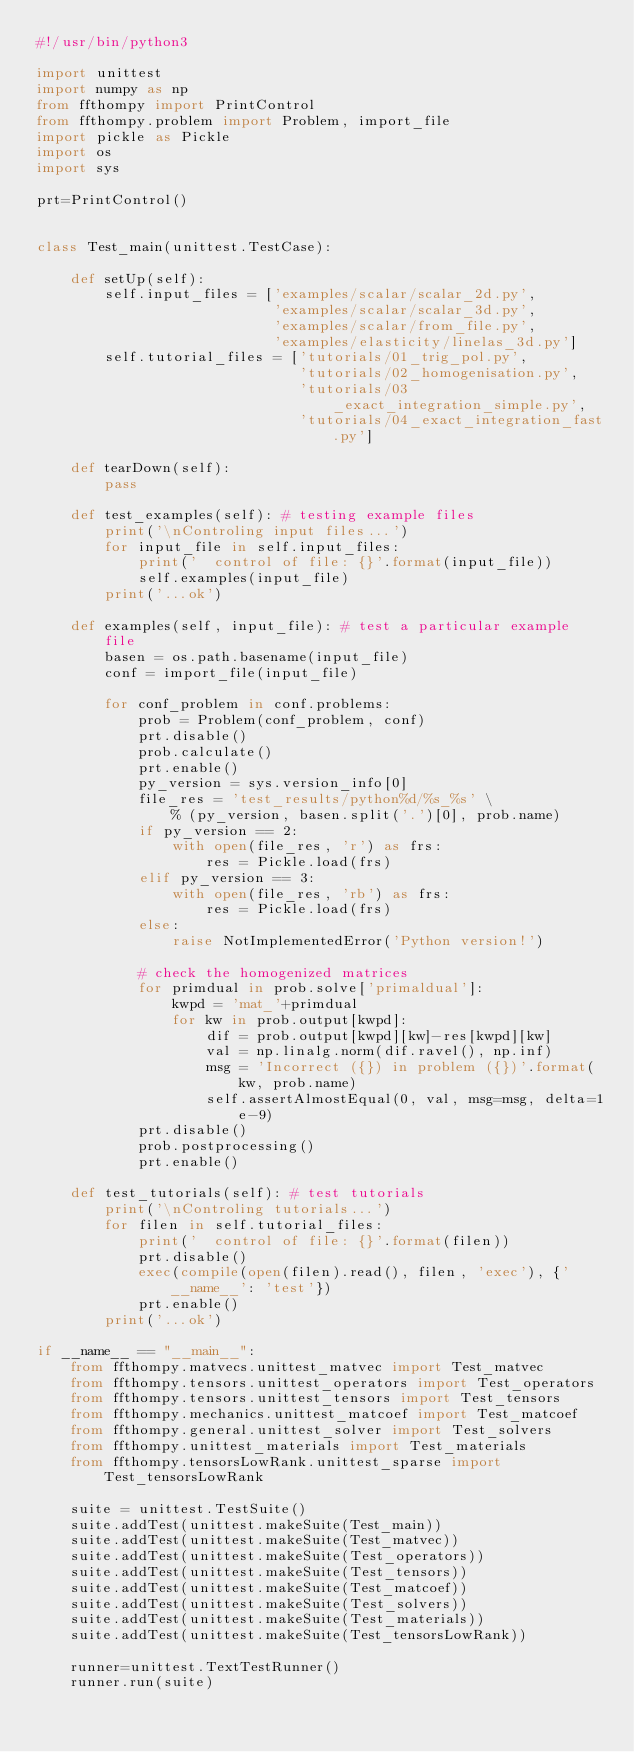<code> <loc_0><loc_0><loc_500><loc_500><_Python_>#!/usr/bin/python3

import unittest
import numpy as np
from ffthompy import PrintControl
from ffthompy.problem import Problem, import_file
import pickle as Pickle
import os
import sys

prt=PrintControl()


class Test_main(unittest.TestCase):

    def setUp(self):
        self.input_files = ['examples/scalar/scalar_2d.py',
                            'examples/scalar/scalar_3d.py',
                            'examples/scalar/from_file.py',
                            'examples/elasticity/linelas_3d.py']
        self.tutorial_files = ['tutorials/01_trig_pol.py',
                               'tutorials/02_homogenisation.py',
                               'tutorials/03_exact_integration_simple.py',
                               'tutorials/04_exact_integration_fast.py']

    def tearDown(self):
        pass

    def test_examples(self): # testing example files
        print('\nControling input files...')
        for input_file in self.input_files:
            print('  control of file: {}'.format(input_file))
            self.examples(input_file)
        print('...ok')

    def examples(self, input_file): # test a particular example file
        basen = os.path.basename(input_file)
        conf = import_file(input_file)

        for conf_problem in conf.problems:
            prob = Problem(conf_problem, conf)
            prt.disable()
            prob.calculate()
            prt.enable()
            py_version = sys.version_info[0]
            file_res = 'test_results/python%d/%s_%s' \
                % (py_version, basen.split('.')[0], prob.name)
            if py_version == 2:
                with open(file_res, 'r') as frs:
                    res = Pickle.load(frs)
            elif py_version == 3:
                with open(file_res, 'rb') as frs:
                    res = Pickle.load(frs)
            else:
                raise NotImplementedError('Python version!')

            # check the homogenized matrices
            for primdual in prob.solve['primaldual']:
                kwpd = 'mat_'+primdual
                for kw in prob.output[kwpd]:
                    dif = prob.output[kwpd][kw]-res[kwpd][kw]
                    val = np.linalg.norm(dif.ravel(), np.inf)
                    msg = 'Incorrect ({}) in problem ({})'.format(kw, prob.name)
                    self.assertAlmostEqual(0, val, msg=msg, delta=1e-9)
            prt.disable()
            prob.postprocessing()
            prt.enable()

    def test_tutorials(self): # test tutorials
        print('\nControling tutorials...')
        for filen in self.tutorial_files:
            print('  control of file: {}'.format(filen))
            prt.disable()
            exec(compile(open(filen).read(), filen, 'exec'), {'__name__': 'test'})
            prt.enable()
        print('...ok')

if __name__ == "__main__":
    from ffthompy.matvecs.unittest_matvec import Test_matvec
    from ffthompy.tensors.unittest_operators import Test_operators
    from ffthompy.tensors.unittest_tensors import Test_tensors
    from ffthompy.mechanics.unittest_matcoef import Test_matcoef
    from ffthompy.general.unittest_solver import Test_solvers
    from ffthompy.unittest_materials import Test_materials
    from ffthompy.tensorsLowRank.unittest_sparse import Test_tensorsLowRank

    suite = unittest.TestSuite()
    suite.addTest(unittest.makeSuite(Test_main))
    suite.addTest(unittest.makeSuite(Test_matvec))
    suite.addTest(unittest.makeSuite(Test_operators))
    suite.addTest(unittest.makeSuite(Test_tensors))
    suite.addTest(unittest.makeSuite(Test_matcoef))
    suite.addTest(unittest.makeSuite(Test_solvers))
    suite.addTest(unittest.makeSuite(Test_materials))
    suite.addTest(unittest.makeSuite(Test_tensorsLowRank))

    runner=unittest.TextTestRunner()
    runner.run(suite)
</code> 